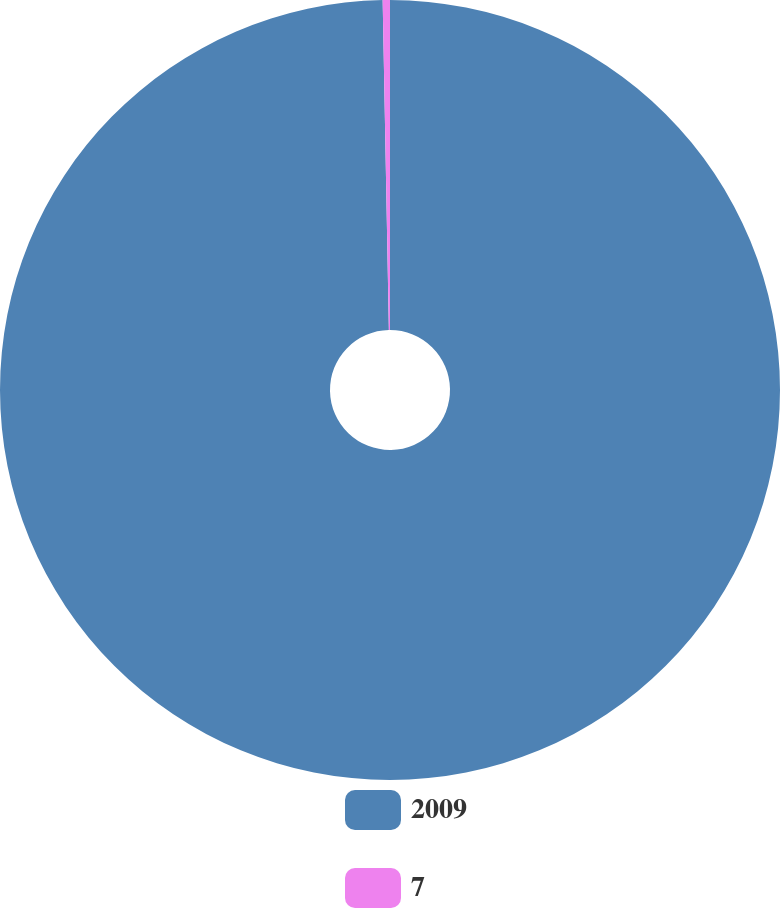<chart> <loc_0><loc_0><loc_500><loc_500><pie_chart><fcel>2009<fcel>7<nl><fcel>99.7%<fcel>0.3%<nl></chart> 